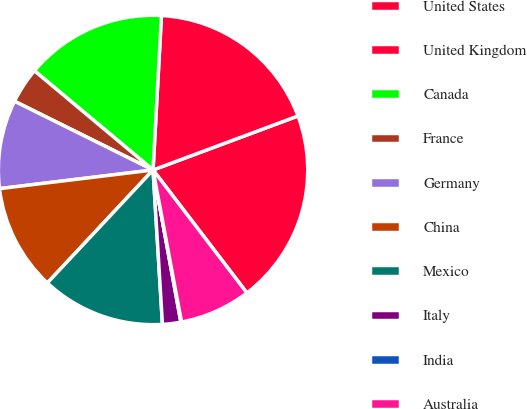Convert chart to OTSL. <chart><loc_0><loc_0><loc_500><loc_500><pie_chart><fcel>United States<fcel>United Kingdom<fcel>Canada<fcel>France<fcel>Germany<fcel>China<fcel>Mexico<fcel>Italy<fcel>India<fcel>Australia<nl><fcel>20.3%<fcel>18.46%<fcel>14.78%<fcel>3.75%<fcel>9.26%<fcel>11.1%<fcel>12.94%<fcel>1.91%<fcel>0.07%<fcel>7.43%<nl></chart> 